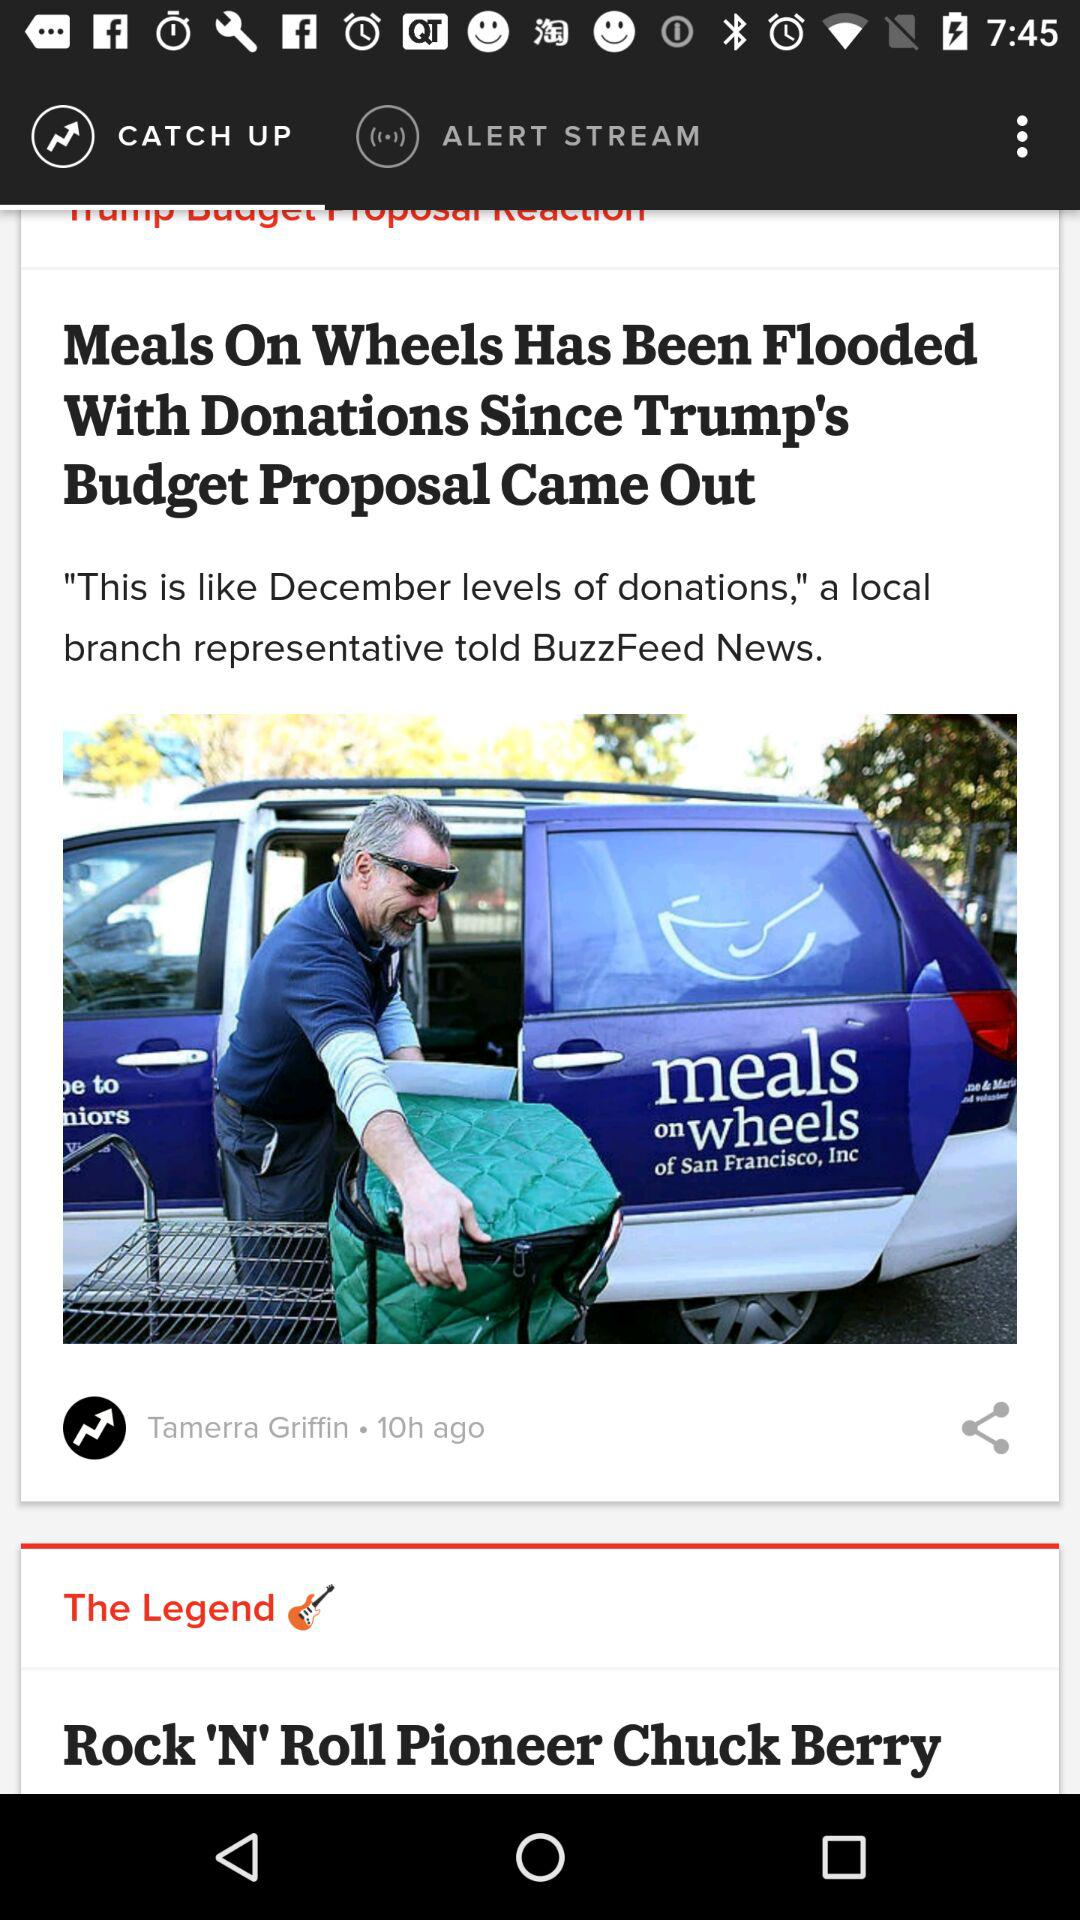Who posted the news about Meals on Wheels? The news about Meals on Wheels was posted by Tamerra Griffin. 